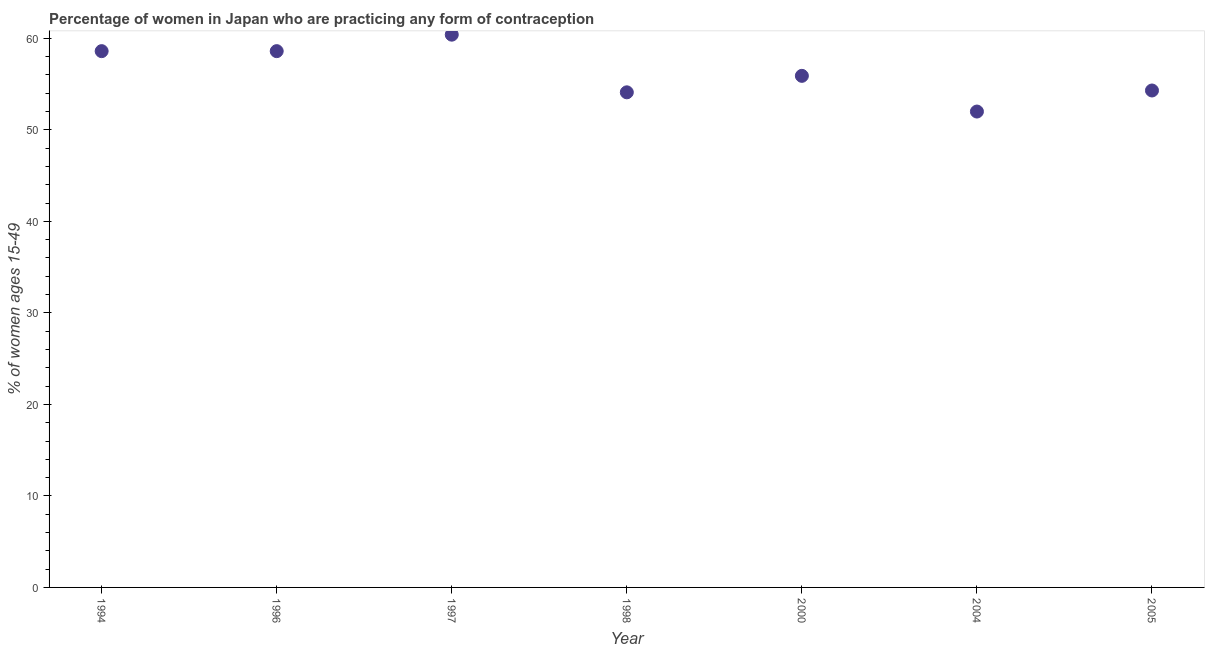What is the contraceptive prevalence in 2004?
Keep it short and to the point. 52. Across all years, what is the maximum contraceptive prevalence?
Give a very brief answer. 60.4. What is the sum of the contraceptive prevalence?
Offer a very short reply. 393.9. What is the difference between the contraceptive prevalence in 1997 and 2005?
Your response must be concise. 6.1. What is the average contraceptive prevalence per year?
Provide a short and direct response. 56.27. What is the median contraceptive prevalence?
Offer a terse response. 55.9. In how many years, is the contraceptive prevalence greater than 50 %?
Keep it short and to the point. 7. Do a majority of the years between 2000 and 1996 (inclusive) have contraceptive prevalence greater than 12 %?
Provide a short and direct response. Yes. What is the ratio of the contraceptive prevalence in 1997 to that in 2000?
Provide a short and direct response. 1.08. Is the contraceptive prevalence in 1994 less than that in 1996?
Provide a succinct answer. No. What is the difference between the highest and the second highest contraceptive prevalence?
Give a very brief answer. 1.8. What is the difference between the highest and the lowest contraceptive prevalence?
Your response must be concise. 8.4. In how many years, is the contraceptive prevalence greater than the average contraceptive prevalence taken over all years?
Your answer should be very brief. 3. How many dotlines are there?
Provide a short and direct response. 1. How many years are there in the graph?
Ensure brevity in your answer.  7. Are the values on the major ticks of Y-axis written in scientific E-notation?
Offer a terse response. No. Does the graph contain any zero values?
Provide a short and direct response. No. What is the title of the graph?
Keep it short and to the point. Percentage of women in Japan who are practicing any form of contraception. What is the label or title of the Y-axis?
Ensure brevity in your answer.  % of women ages 15-49. What is the % of women ages 15-49 in 1994?
Give a very brief answer. 58.6. What is the % of women ages 15-49 in 1996?
Your response must be concise. 58.6. What is the % of women ages 15-49 in 1997?
Your response must be concise. 60.4. What is the % of women ages 15-49 in 1998?
Make the answer very short. 54.1. What is the % of women ages 15-49 in 2000?
Provide a short and direct response. 55.9. What is the % of women ages 15-49 in 2004?
Your response must be concise. 52. What is the % of women ages 15-49 in 2005?
Your answer should be very brief. 54.3. What is the difference between the % of women ages 15-49 in 1994 and 1996?
Provide a succinct answer. 0. What is the difference between the % of women ages 15-49 in 1994 and 1997?
Keep it short and to the point. -1.8. What is the difference between the % of women ages 15-49 in 1994 and 2000?
Offer a very short reply. 2.7. What is the difference between the % of women ages 15-49 in 1994 and 2005?
Make the answer very short. 4.3. What is the difference between the % of women ages 15-49 in 1996 and 1998?
Keep it short and to the point. 4.5. What is the difference between the % of women ages 15-49 in 1996 and 2004?
Keep it short and to the point. 6.6. What is the difference between the % of women ages 15-49 in 1996 and 2005?
Provide a succinct answer. 4.3. What is the difference between the % of women ages 15-49 in 1997 and 2000?
Your response must be concise. 4.5. What is the difference between the % of women ages 15-49 in 1998 and 2005?
Keep it short and to the point. -0.2. What is the difference between the % of women ages 15-49 in 2000 and 2004?
Make the answer very short. 3.9. What is the difference between the % of women ages 15-49 in 2000 and 2005?
Keep it short and to the point. 1.6. What is the difference between the % of women ages 15-49 in 2004 and 2005?
Offer a terse response. -2.3. What is the ratio of the % of women ages 15-49 in 1994 to that in 1997?
Make the answer very short. 0.97. What is the ratio of the % of women ages 15-49 in 1994 to that in 1998?
Your answer should be very brief. 1.08. What is the ratio of the % of women ages 15-49 in 1994 to that in 2000?
Make the answer very short. 1.05. What is the ratio of the % of women ages 15-49 in 1994 to that in 2004?
Provide a short and direct response. 1.13. What is the ratio of the % of women ages 15-49 in 1994 to that in 2005?
Your answer should be compact. 1.08. What is the ratio of the % of women ages 15-49 in 1996 to that in 1997?
Offer a very short reply. 0.97. What is the ratio of the % of women ages 15-49 in 1996 to that in 1998?
Provide a succinct answer. 1.08. What is the ratio of the % of women ages 15-49 in 1996 to that in 2000?
Ensure brevity in your answer.  1.05. What is the ratio of the % of women ages 15-49 in 1996 to that in 2004?
Offer a very short reply. 1.13. What is the ratio of the % of women ages 15-49 in 1996 to that in 2005?
Give a very brief answer. 1.08. What is the ratio of the % of women ages 15-49 in 1997 to that in 1998?
Ensure brevity in your answer.  1.12. What is the ratio of the % of women ages 15-49 in 1997 to that in 2000?
Your answer should be very brief. 1.08. What is the ratio of the % of women ages 15-49 in 1997 to that in 2004?
Keep it short and to the point. 1.16. What is the ratio of the % of women ages 15-49 in 1997 to that in 2005?
Your answer should be compact. 1.11. What is the ratio of the % of women ages 15-49 in 1998 to that in 2005?
Your response must be concise. 1. What is the ratio of the % of women ages 15-49 in 2000 to that in 2004?
Your answer should be very brief. 1.07. What is the ratio of the % of women ages 15-49 in 2004 to that in 2005?
Your answer should be compact. 0.96. 